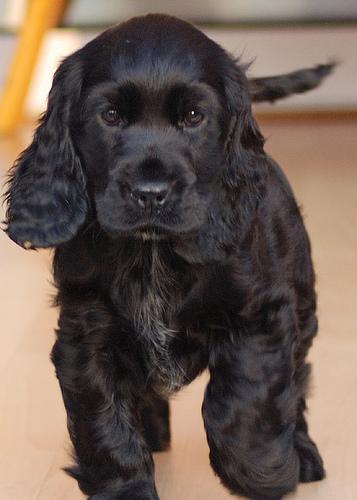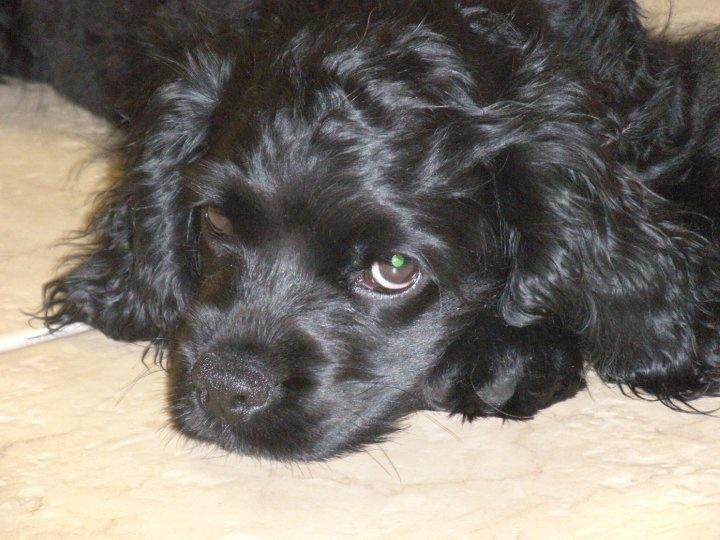The first image is the image on the left, the second image is the image on the right. For the images displayed, is the sentence "A single dog is posed on grass in the left image." factually correct? Answer yes or no. No. The first image is the image on the left, the second image is the image on the right. For the images shown, is this caption "One dark puppy is standing, and the other dark puppy is reclining." true? Answer yes or no. Yes. 